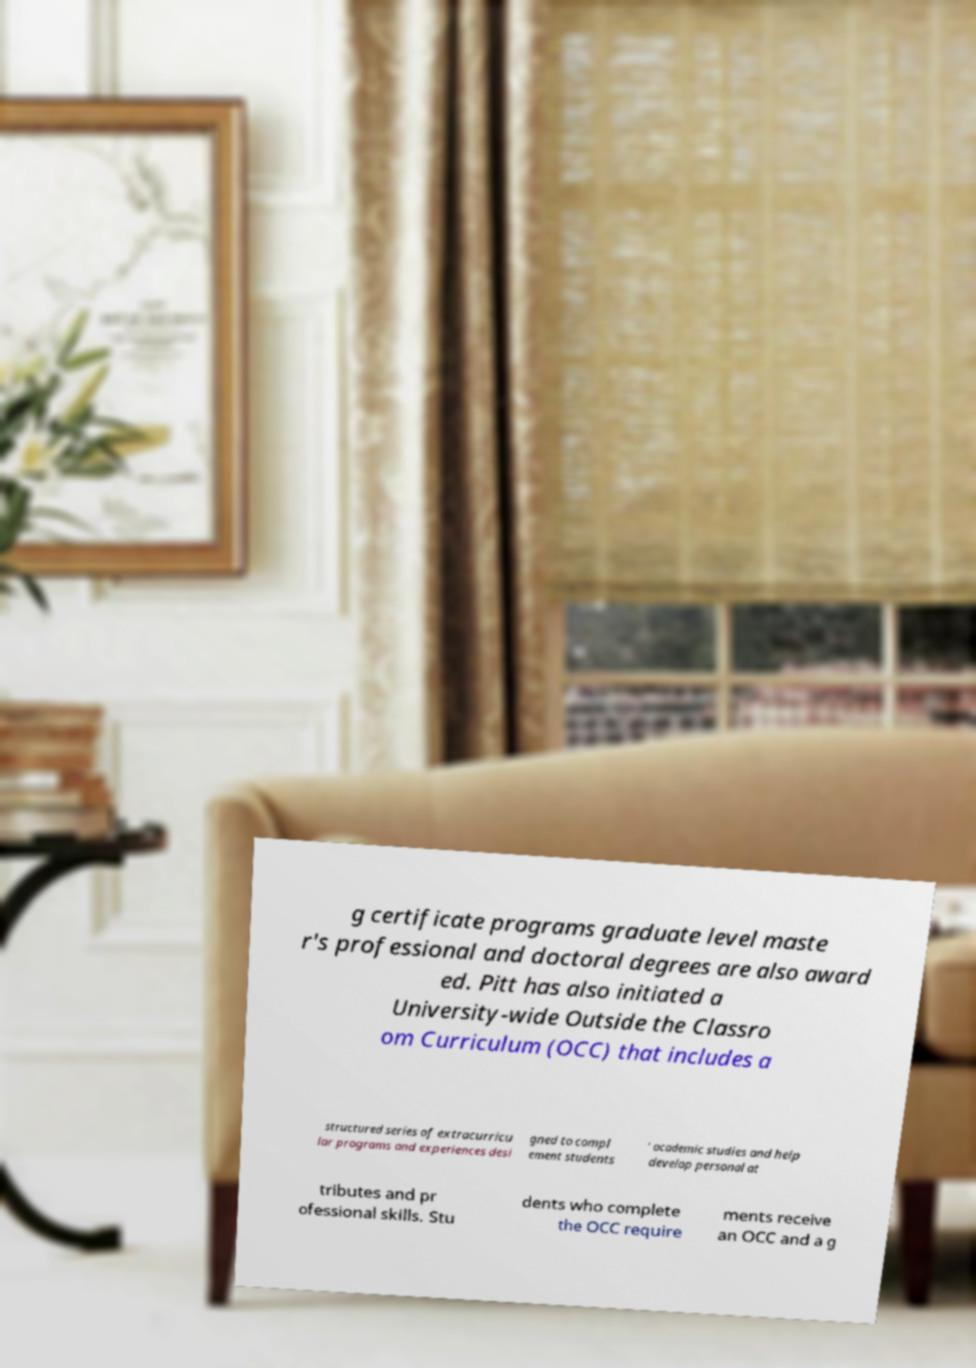Could you extract and type out the text from this image? g certificate programs graduate level maste r's professional and doctoral degrees are also award ed. Pitt has also initiated a University-wide Outside the Classro om Curriculum (OCC) that includes a structured series of extracurricu lar programs and experiences desi gned to compl ement students ' academic studies and help develop personal at tributes and pr ofessional skills. Stu dents who complete the OCC require ments receive an OCC and a g 